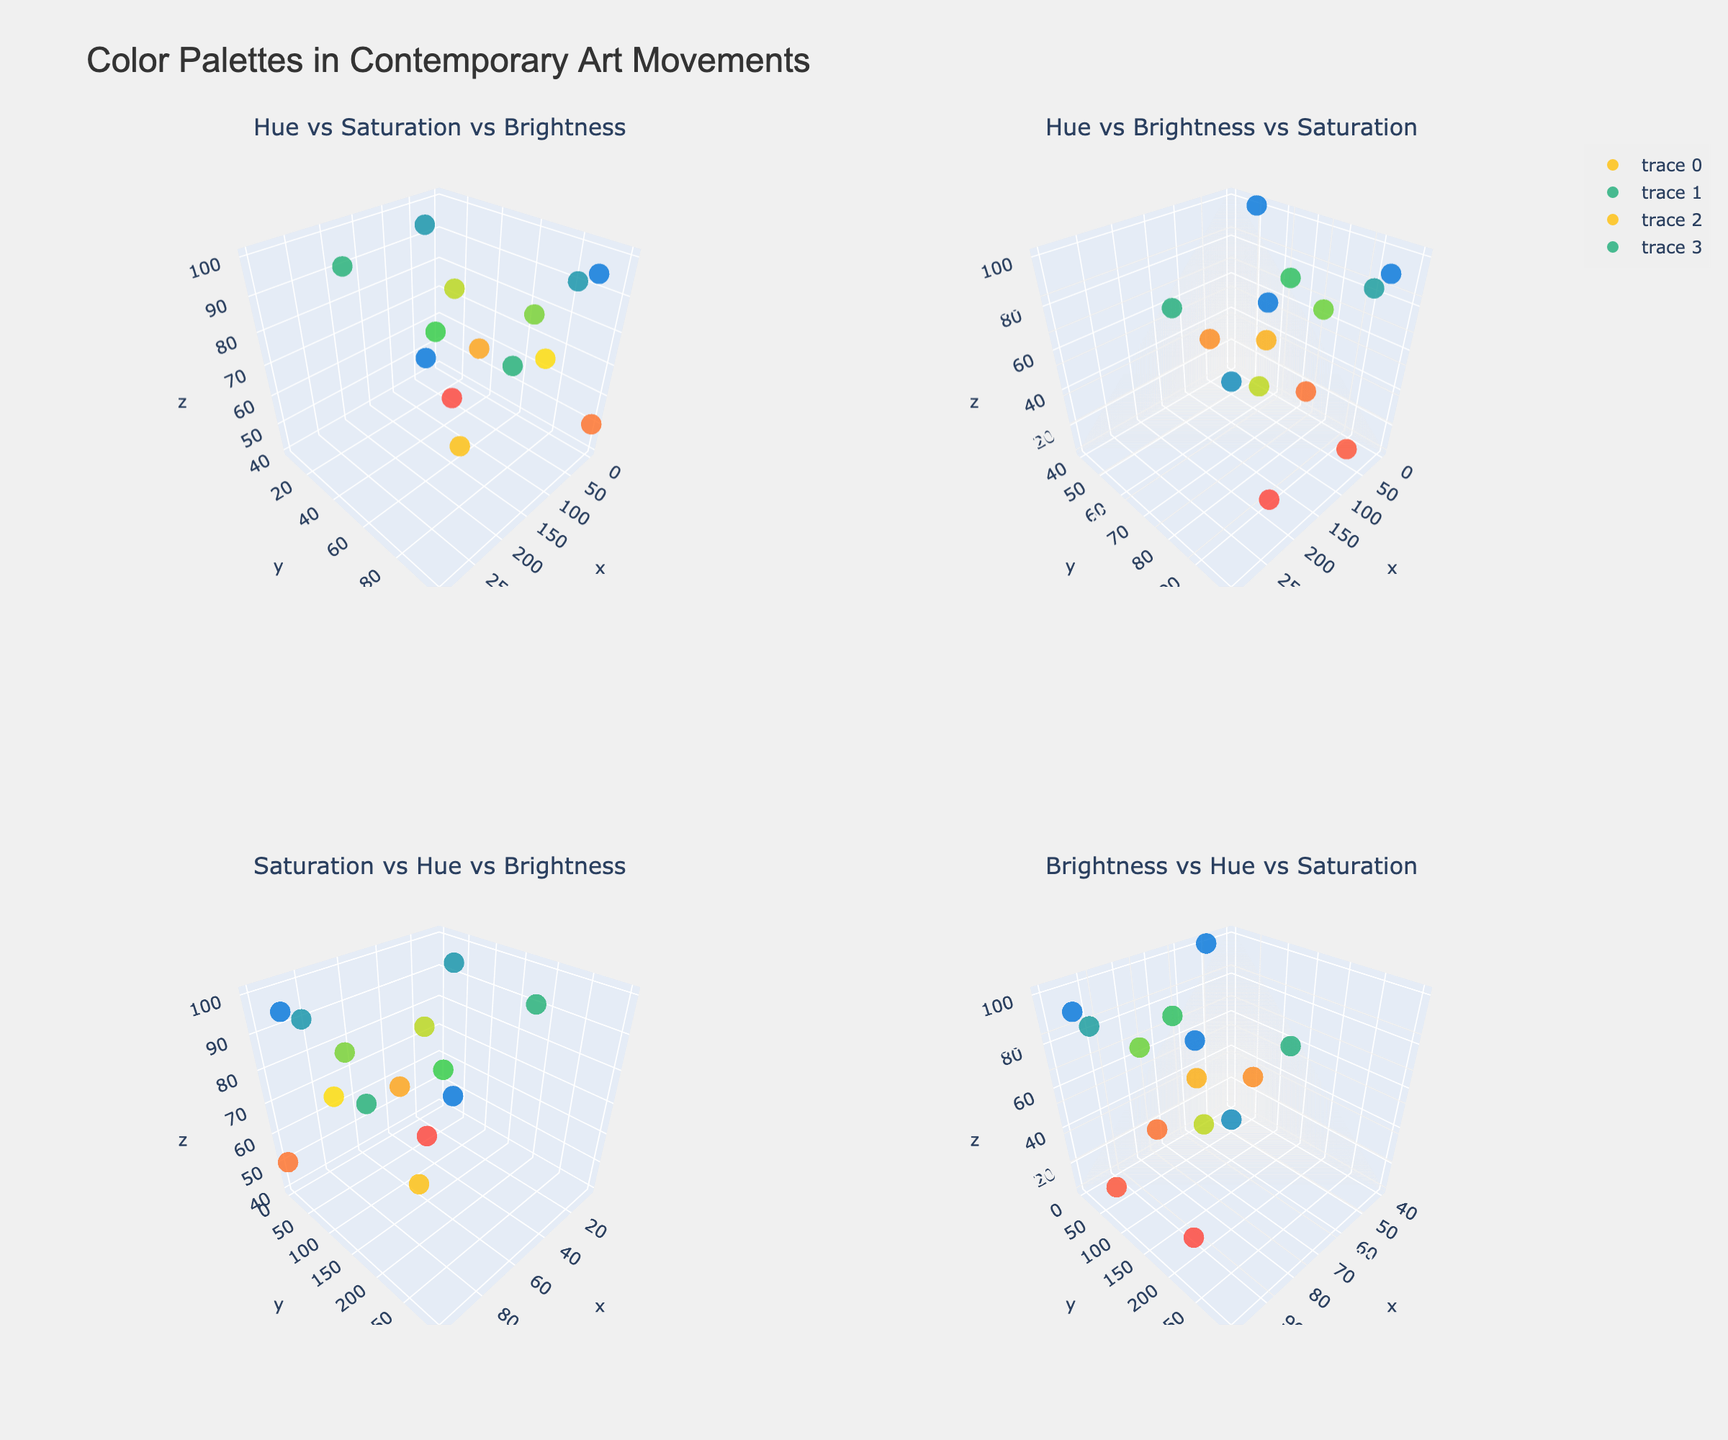What do the four subplots in the figure represent? The four subplots each show the relationships between different combinations of hue, saturation, and brightness. The titles are: 'Hue vs Saturation vs Brightness', 'Hue vs Brightness vs Saturation', 'Saturation vs Hue vs Brightness', and 'Brightness vs Hue vs Saturation'.
Answer: Four relationships: Hue-Saturation-Brightness, Hue-Brightness-Saturation, Saturation-Hue-Brightness, Brightness-Hue-Saturation Which plot has the highest brightness value and what movement does it correspond to? Look for the plot 'Brightness vs Hue vs Saturation'. Identify the data point with the highest brightness value, which corresponds to the 'Interdisciplinary' movement with the artwork 'The Weather Project (Olafur Eliasson)'.
Answer: Interdisciplinary; The Weather Project (Olafur Eliasson) How many data points have saturation values equal to 100 in the 'Hue vs Saturation vs Brightness' plot? Observe the 'Hue vs Saturation vs Brightness' plot. Count the data points with a saturation value of 100. There are 3 such points corresponding to 'Pop Art: Whaam!', 'Minimalism: Voice of Fire', and 'Interdisciplinary: The Weather Project'.
Answer: 3 data points Which movement shows the most variety in hue across the 'Hue vs Saturation vs Brightness' plot? Observe the 'Hue vs Saturation vs Brightness' plot. The movements with the most varied hue values will have data points spread across a wide range of hue values. 'Pop Art' shows hues at 45 and 200, representing the widest range in hue.
Answer: Pop Art Compare the brightness of 'Abstract Expressionism: Blue Poles' and 'Eco-Art: The Lightning Field' in the 'Brightness vs Hue vs Saturation' plot. Which one is higher? Observe the 'Brightness vs Hue vs Saturation' plot. The data point for 'Eco-Art: The Lightning Field' has a brightness of 95, which is higher than 'Abstract Expressionism: Blue Poles' with a brightness of 65.
Answer: Eco-Art: The Lightning Field What is the average hue value of all artworks in the 'Saturation vs Hue vs Brightness' plot? Observe the 'Saturation vs Hue vs Brightness' plot. Extract the hue values for all data points and calculate their average: (220 + 30 + 45 + 200 + 15 + 0 + 40 + 50 + 180 + 300 + 45 + 25 + 60 + 180) / 14 = 98.93.
Answer: 98.93 Identify the artwork with the lowest saturation in the 'Saturation vs Hue vs Brightness' plot. Observe the 'Saturation vs Hue vs Brightness' plot. Identify the data point with the lowest saturation value, which corresponds to 'Interdisciplinary: Cloud Gate (Anish Kapoor)' with a saturation of 5.
Answer: Interdisciplinary: Cloud Gate (Anish Kapoor) Which art movement predominantly uses bright colors based on all subplots? Observe all subplots, particularly focusing on the brightness axis. The 'Interdisciplinary' movement has the highest brightness values (The Weather Project at 100 and Cloud Gate at 90), indicating a predominance of bright colors.
Answer: Interdisciplinary In which subplot and artwork does the hue value of 'Genesis (Yayoi Kusama)' appear at its maximum value? Observe all subplots for hue values. The hue value of 300 (the maximum) corresponds to 'Digital Art: Genesis (Yayoi Kusama)', visible prominently in the 'Saturation vs Hue vs Brightness' plot.
Answer: Saturation vs Hue vs Brightness; Digital Art: Genesis (Yayoi Kusama) 